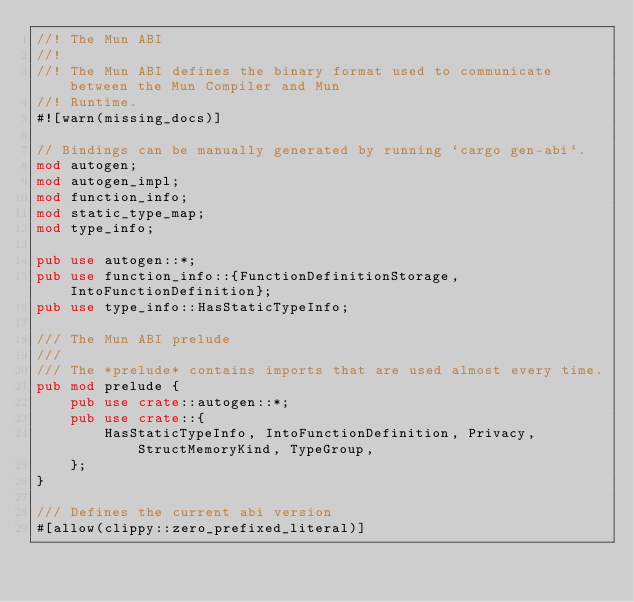Convert code to text. <code><loc_0><loc_0><loc_500><loc_500><_Rust_>//! The Mun ABI
//!
//! The Mun ABI defines the binary format used to communicate between the Mun Compiler and Mun
//! Runtime.
#![warn(missing_docs)]

// Bindings can be manually generated by running `cargo gen-abi`.
mod autogen;
mod autogen_impl;
mod function_info;
mod static_type_map;
mod type_info;

pub use autogen::*;
pub use function_info::{FunctionDefinitionStorage, IntoFunctionDefinition};
pub use type_info::HasStaticTypeInfo;

/// The Mun ABI prelude
///
/// The *prelude* contains imports that are used almost every time.
pub mod prelude {
    pub use crate::autogen::*;
    pub use crate::{
        HasStaticTypeInfo, IntoFunctionDefinition, Privacy, StructMemoryKind, TypeGroup,
    };
}

/// Defines the current abi version
#[allow(clippy::zero_prefixed_literal)]</code> 